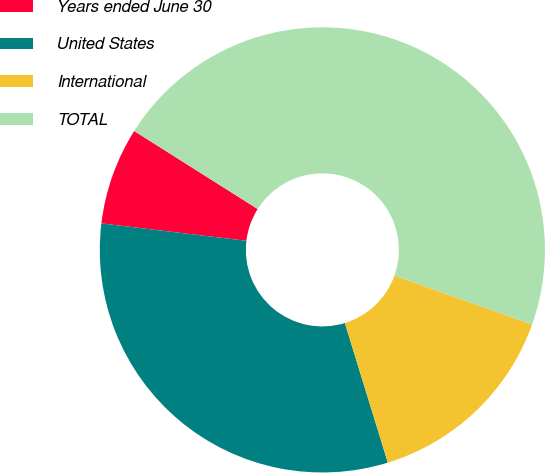<chart> <loc_0><loc_0><loc_500><loc_500><pie_chart><fcel>Years ended June 30<fcel>United States<fcel>International<fcel>TOTAL<nl><fcel>7.07%<fcel>31.65%<fcel>14.81%<fcel>46.47%<nl></chart> 